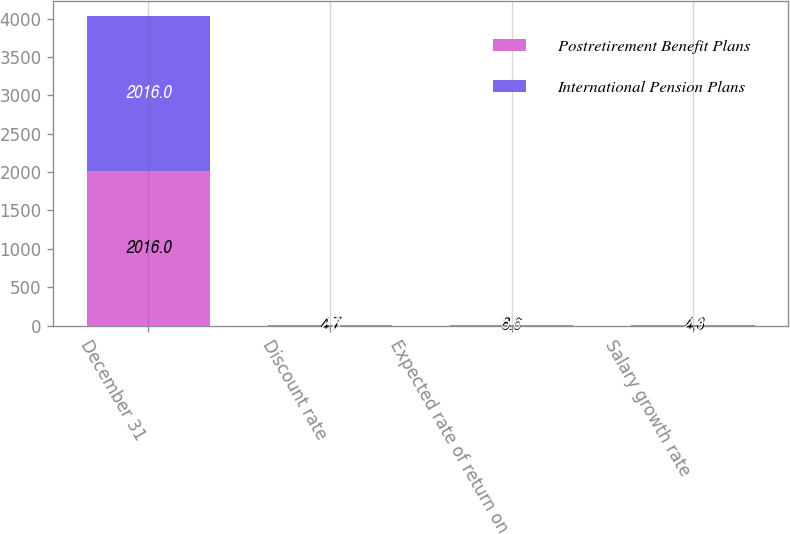Convert chart. <chart><loc_0><loc_0><loc_500><loc_500><stacked_bar_chart><ecel><fcel>December 31<fcel>Discount rate<fcel>Expected rate of return on<fcel>Salary growth rate<nl><fcel>Postretirement Benefit Plans<fcel>2016<fcel>4.7<fcel>8.6<fcel>4.3<nl><fcel>International Pension Plans<fcel>2016<fcel>2.8<fcel>5.6<fcel>2.9<nl></chart> 